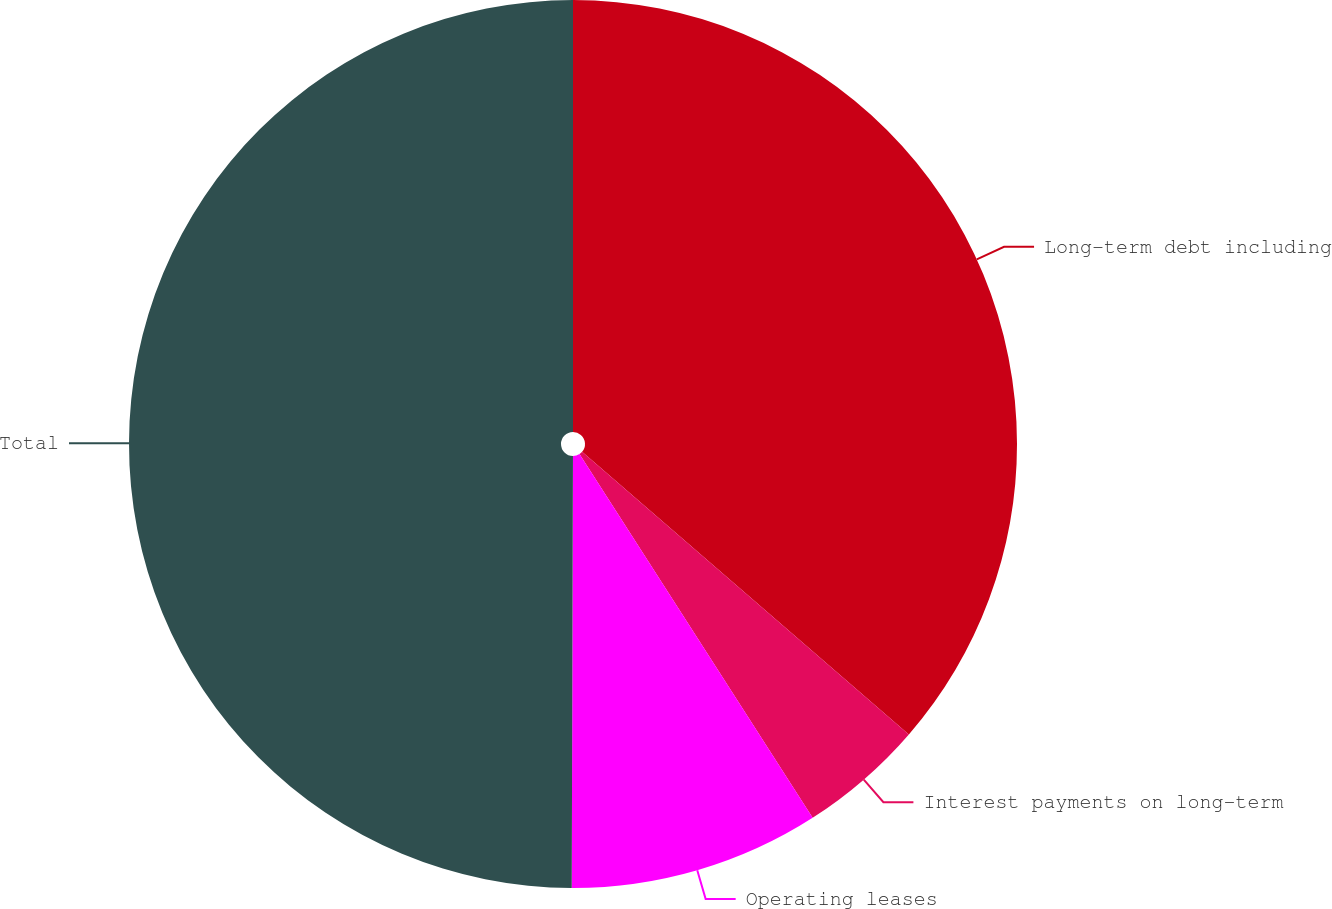<chart> <loc_0><loc_0><loc_500><loc_500><pie_chart><fcel>Long-term debt including<fcel>Interest payments on long-term<fcel>Operating leases<fcel>Total<nl><fcel>36.35%<fcel>4.58%<fcel>9.12%<fcel>49.96%<nl></chart> 